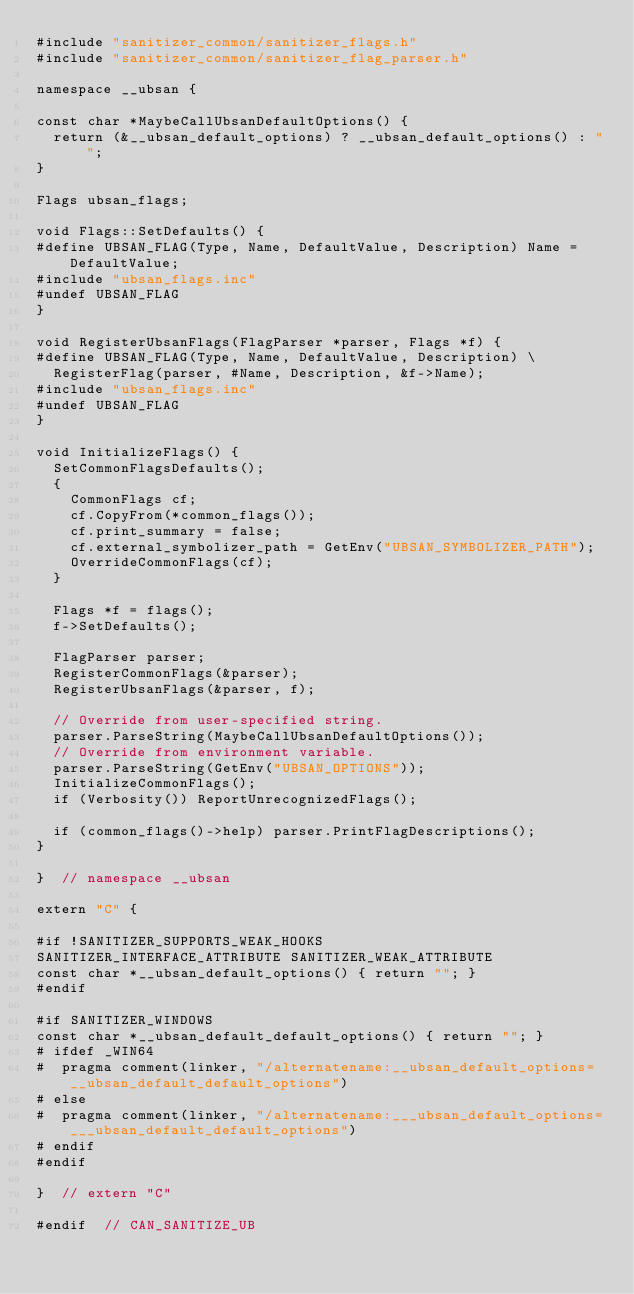Convert code to text. <code><loc_0><loc_0><loc_500><loc_500><_C++_>#include "sanitizer_common/sanitizer_flags.h"
#include "sanitizer_common/sanitizer_flag_parser.h"

namespace __ubsan {

const char *MaybeCallUbsanDefaultOptions() {
  return (&__ubsan_default_options) ? __ubsan_default_options() : "";
}

Flags ubsan_flags;

void Flags::SetDefaults() {
#define UBSAN_FLAG(Type, Name, DefaultValue, Description) Name = DefaultValue;
#include "ubsan_flags.inc"
#undef UBSAN_FLAG
}

void RegisterUbsanFlags(FlagParser *parser, Flags *f) {
#define UBSAN_FLAG(Type, Name, DefaultValue, Description) \
  RegisterFlag(parser, #Name, Description, &f->Name);
#include "ubsan_flags.inc"
#undef UBSAN_FLAG
}

void InitializeFlags() {
  SetCommonFlagsDefaults();
  {
    CommonFlags cf;
    cf.CopyFrom(*common_flags());
    cf.print_summary = false;
    cf.external_symbolizer_path = GetEnv("UBSAN_SYMBOLIZER_PATH");
    OverrideCommonFlags(cf);
  }

  Flags *f = flags();
  f->SetDefaults();

  FlagParser parser;
  RegisterCommonFlags(&parser);
  RegisterUbsanFlags(&parser, f);

  // Override from user-specified string.
  parser.ParseString(MaybeCallUbsanDefaultOptions());
  // Override from environment variable.
  parser.ParseString(GetEnv("UBSAN_OPTIONS"));
  InitializeCommonFlags();
  if (Verbosity()) ReportUnrecognizedFlags();

  if (common_flags()->help) parser.PrintFlagDescriptions();
}

}  // namespace __ubsan

extern "C" {

#if !SANITIZER_SUPPORTS_WEAK_HOOKS
SANITIZER_INTERFACE_ATTRIBUTE SANITIZER_WEAK_ATTRIBUTE
const char *__ubsan_default_options() { return ""; }
#endif

#if SANITIZER_WINDOWS
const char *__ubsan_default_default_options() { return ""; }
# ifdef _WIN64
#  pragma comment(linker, "/alternatename:__ubsan_default_options=__ubsan_default_default_options")
# else
#  pragma comment(linker, "/alternatename:___ubsan_default_options=___ubsan_default_default_options")
# endif
#endif

}  // extern "C"

#endif  // CAN_SANITIZE_UB
</code> 